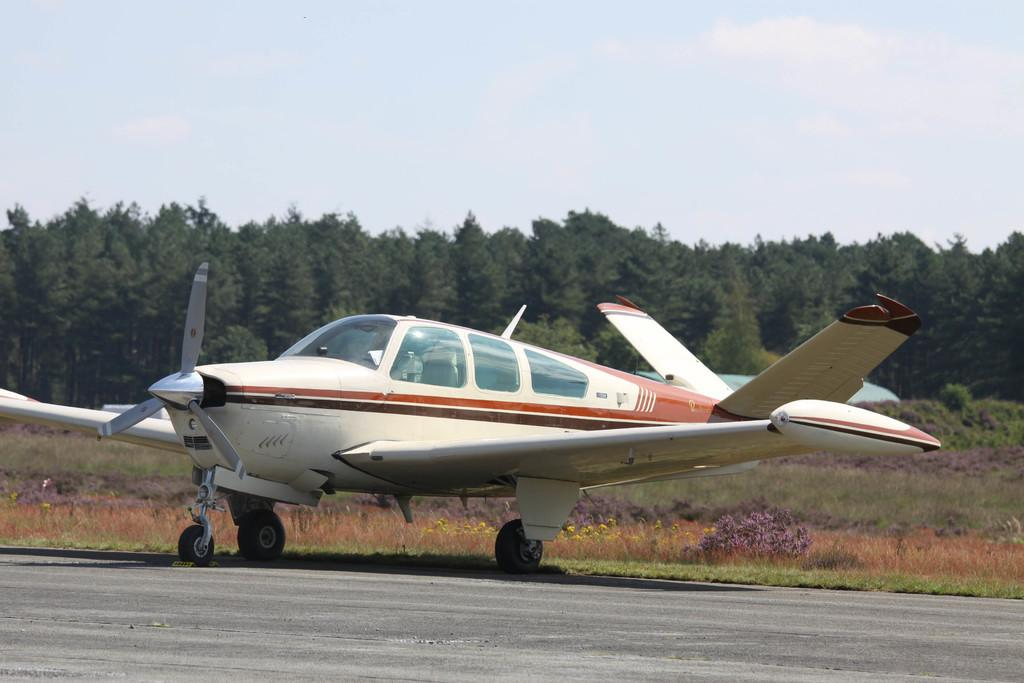What is the main subject of the image? The main subject of the image is an airplane on the ground. What can be seen in the image besides the airplane? Trees are visible in the image. What is visible in the background of the image? The sky is visible in the background of the image. What is the condition of the sky in the image? Clouds are present in the sky. What is the income of the person driving the airplane in the image? There is no person driving the airplane in the image, as airplanes are not driven like cars. Additionally, income is not a visual detail that can be determined from the image. 